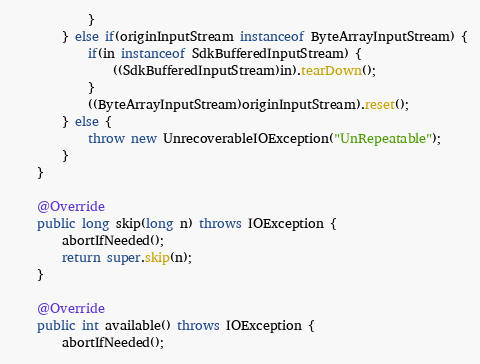Convert code to text. <code><loc_0><loc_0><loc_500><loc_500><_Java_>			}
		} else if(originInputStream instanceof ByteArrayInputStream) {
			if(in instanceof SdkBufferedInputStream) {
				((SdkBufferedInputStream)in).tearDown();
			}
			((ByteArrayInputStream)originInputStream).reset();
		} else {
			throw new UnrecoverableIOException("UnRepeatable");
		}
	}

	@Override
	public long skip(long n) throws IOException {
		abortIfNeeded();
		return super.skip(n);
	}

	@Override
	public int available() throws IOException {
		abortIfNeeded();</code> 